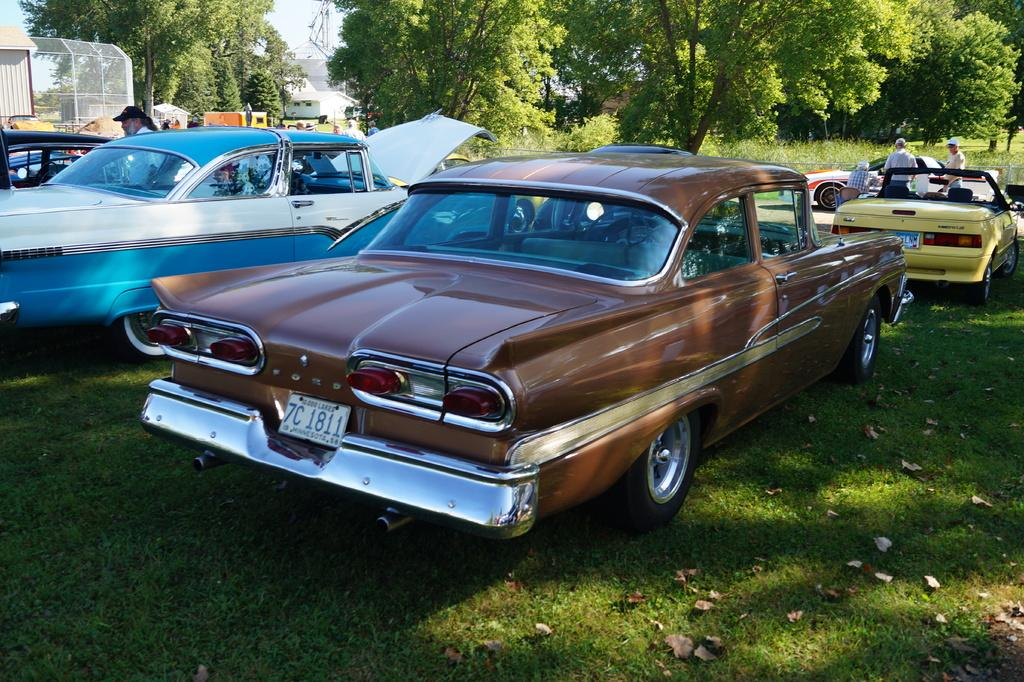What type of vehicles can be seen in the image? There are cars in the image. What are the people in the image doing? The people in the image are standing. What type of vegetation is present at the bottom of the image? Grass is present at the bottom of the image. What type of structures can be seen in the background of the image? There are buildings and a tower in the background of the image. What type of objects can be seen in the background of the image? There are poles in the background of the image. What is the opinion of the sugar on the quilt in the image? There is no sugar or quilt present in the image, so it is not possible to determine an opinion about them. 